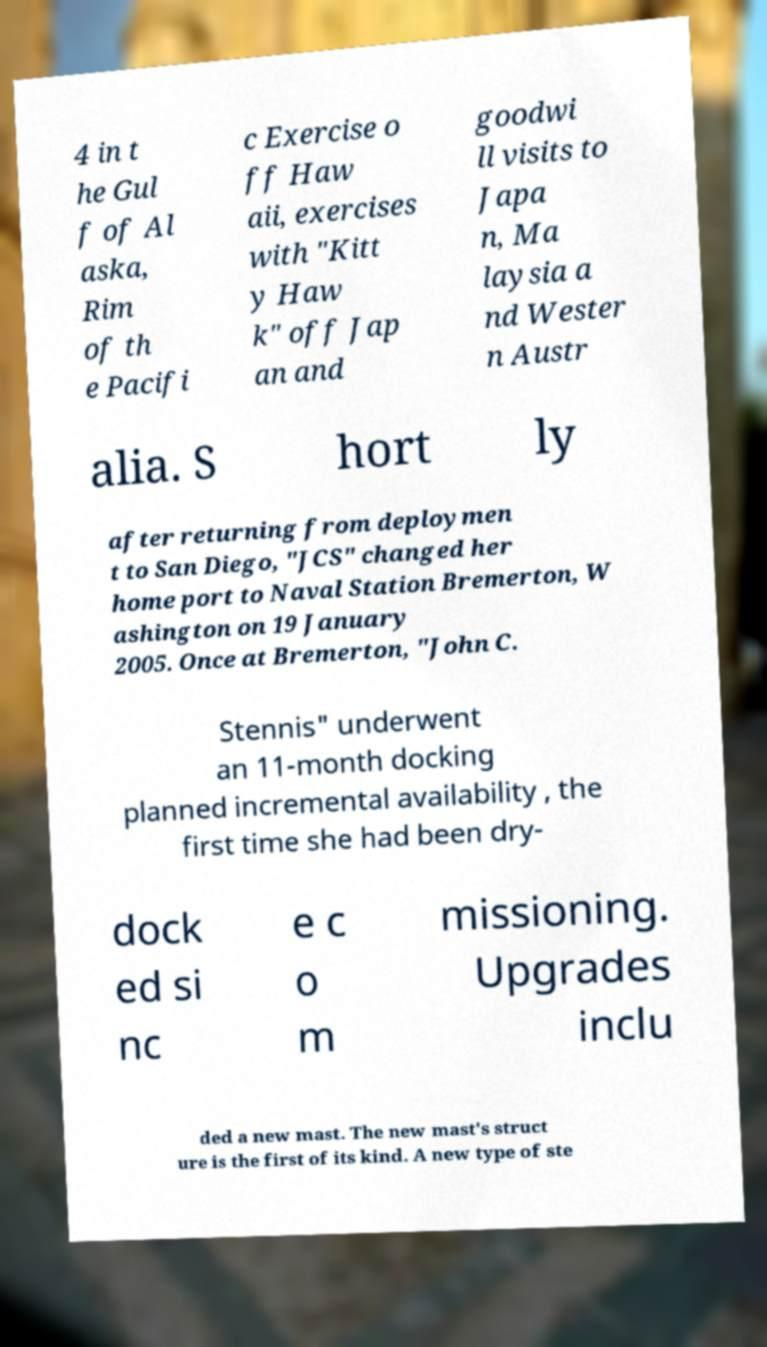There's text embedded in this image that I need extracted. Can you transcribe it verbatim? 4 in t he Gul f of Al aska, Rim of th e Pacifi c Exercise o ff Haw aii, exercises with "Kitt y Haw k" off Jap an and goodwi ll visits to Japa n, Ma laysia a nd Wester n Austr alia. S hort ly after returning from deploymen t to San Diego, "JCS" changed her home port to Naval Station Bremerton, W ashington on 19 January 2005. Once at Bremerton, "John C. Stennis" underwent an 11-month docking planned incremental availability , the first time she had been dry- dock ed si nc e c o m missioning. Upgrades inclu ded a new mast. The new mast's struct ure is the first of its kind. A new type of ste 